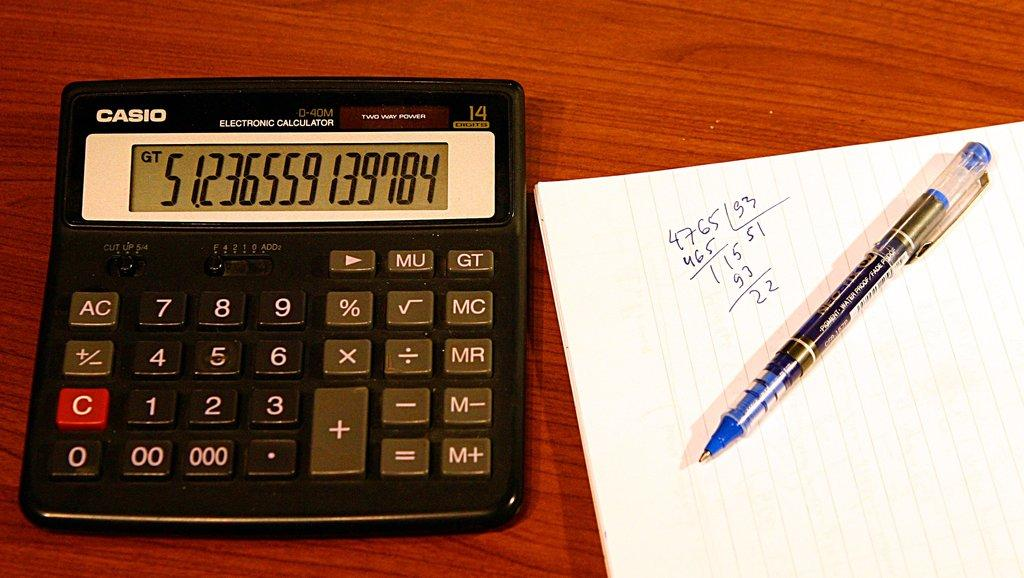Provide a one-sentence caption for the provided image. A Casio brand calculator next to a pen and paper. 